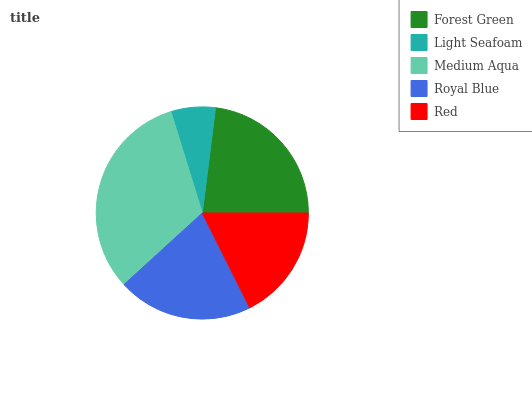Is Light Seafoam the minimum?
Answer yes or no. Yes. Is Medium Aqua the maximum?
Answer yes or no. Yes. Is Medium Aqua the minimum?
Answer yes or no. No. Is Light Seafoam the maximum?
Answer yes or no. No. Is Medium Aqua greater than Light Seafoam?
Answer yes or no. Yes. Is Light Seafoam less than Medium Aqua?
Answer yes or no. Yes. Is Light Seafoam greater than Medium Aqua?
Answer yes or no. No. Is Medium Aqua less than Light Seafoam?
Answer yes or no. No. Is Royal Blue the high median?
Answer yes or no. Yes. Is Royal Blue the low median?
Answer yes or no. Yes. Is Forest Green the high median?
Answer yes or no. No. Is Medium Aqua the low median?
Answer yes or no. No. 